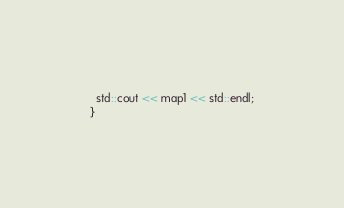<code> <loc_0><loc_0><loc_500><loc_500><_C++_>  std::cout << map1 << std::endl;
}
</code> 